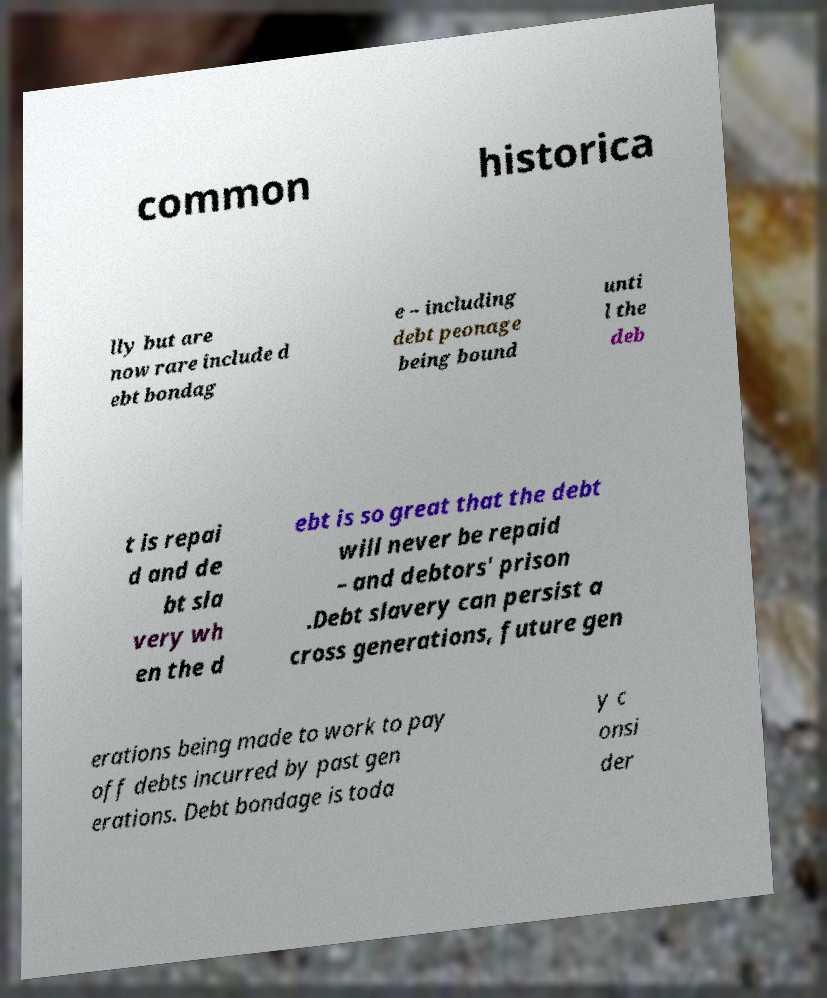What messages or text are displayed in this image? I need them in a readable, typed format. common historica lly but are now rare include d ebt bondag e – including debt peonage being bound unti l the deb t is repai d and de bt sla very wh en the d ebt is so great that the debt will never be repaid – and debtors' prison .Debt slavery can persist a cross generations, future gen erations being made to work to pay off debts incurred by past gen erations. Debt bondage is toda y c onsi der 